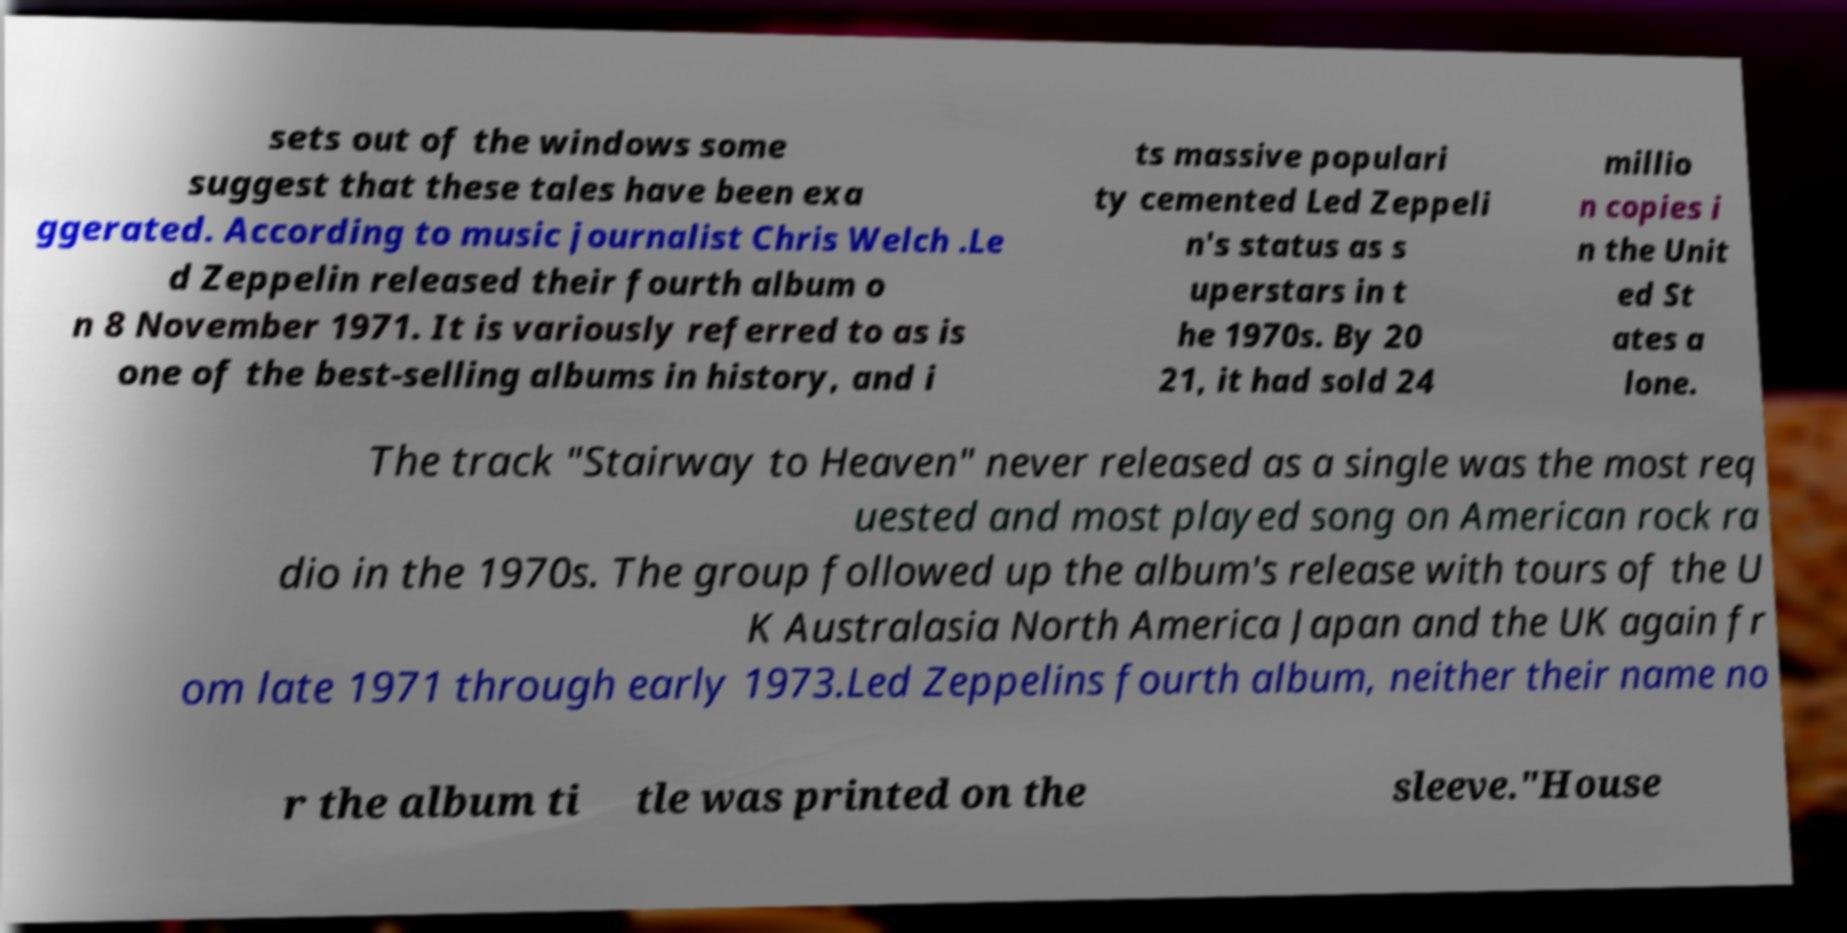Can you read and provide the text displayed in the image?This photo seems to have some interesting text. Can you extract and type it out for me? sets out of the windows some suggest that these tales have been exa ggerated. According to music journalist Chris Welch .Le d Zeppelin released their fourth album o n 8 November 1971. It is variously referred to as is one of the best-selling albums in history, and i ts massive populari ty cemented Led Zeppeli n's status as s uperstars in t he 1970s. By 20 21, it had sold 24 millio n copies i n the Unit ed St ates a lone. The track "Stairway to Heaven" never released as a single was the most req uested and most played song on American rock ra dio in the 1970s. The group followed up the album's release with tours of the U K Australasia North America Japan and the UK again fr om late 1971 through early 1973.Led Zeppelins fourth album, neither their name no r the album ti tle was printed on the sleeve."House 